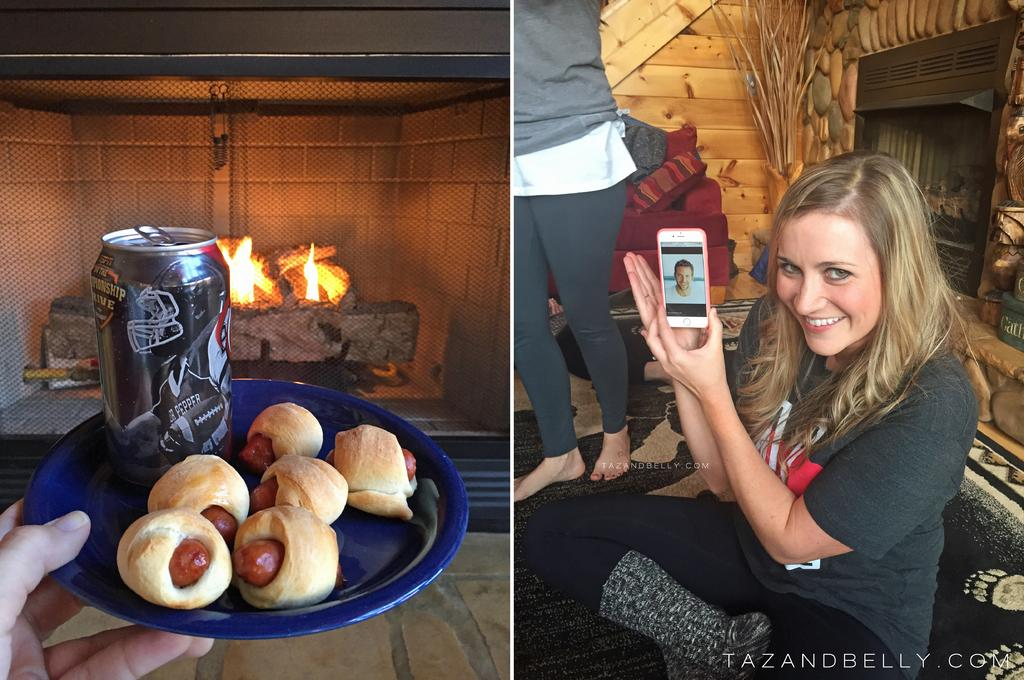What is the woman in the image doing? The woman is sitting on the floor. What is the woman holding in the image? The woman is holding a mobile. Who is standing beside the woman? There is a person standing beside the woman. What is on the plate in the image? There is a tin and food on the plate. What can be seen in the background of the image? There is a fire visible in the image. What type of rock is the woman using to play chess in the image? There is no rock or chess game present in the image. 